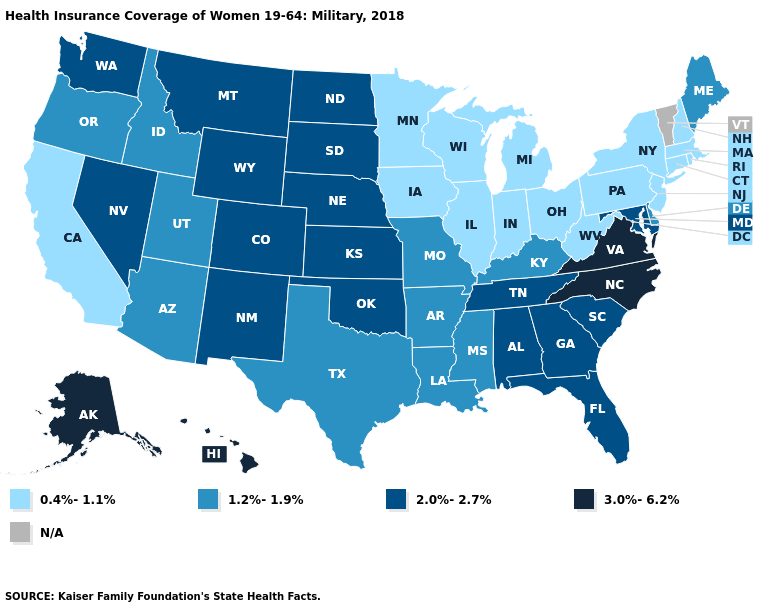Which states have the highest value in the USA?
Quick response, please. Alaska, Hawaii, North Carolina, Virginia. What is the lowest value in the MidWest?
Answer briefly. 0.4%-1.1%. What is the lowest value in the USA?
Keep it brief. 0.4%-1.1%. Name the states that have a value in the range 2.0%-2.7%?
Give a very brief answer. Alabama, Colorado, Florida, Georgia, Kansas, Maryland, Montana, Nebraska, Nevada, New Mexico, North Dakota, Oklahoma, South Carolina, South Dakota, Tennessee, Washington, Wyoming. Does Hawaii have the highest value in the USA?
Write a very short answer. Yes. Does the map have missing data?
Give a very brief answer. Yes. What is the value of California?
Concise answer only. 0.4%-1.1%. How many symbols are there in the legend?
Write a very short answer. 5. Which states hav the highest value in the MidWest?
Give a very brief answer. Kansas, Nebraska, North Dakota, South Dakota. Which states hav the highest value in the South?
Concise answer only. North Carolina, Virginia. Does North Carolina have the highest value in the USA?
Concise answer only. Yes. Among the states that border North Carolina , which have the highest value?
Keep it brief. Virginia. Does California have the lowest value in the West?
Write a very short answer. Yes. Name the states that have a value in the range N/A?
Write a very short answer. Vermont. 